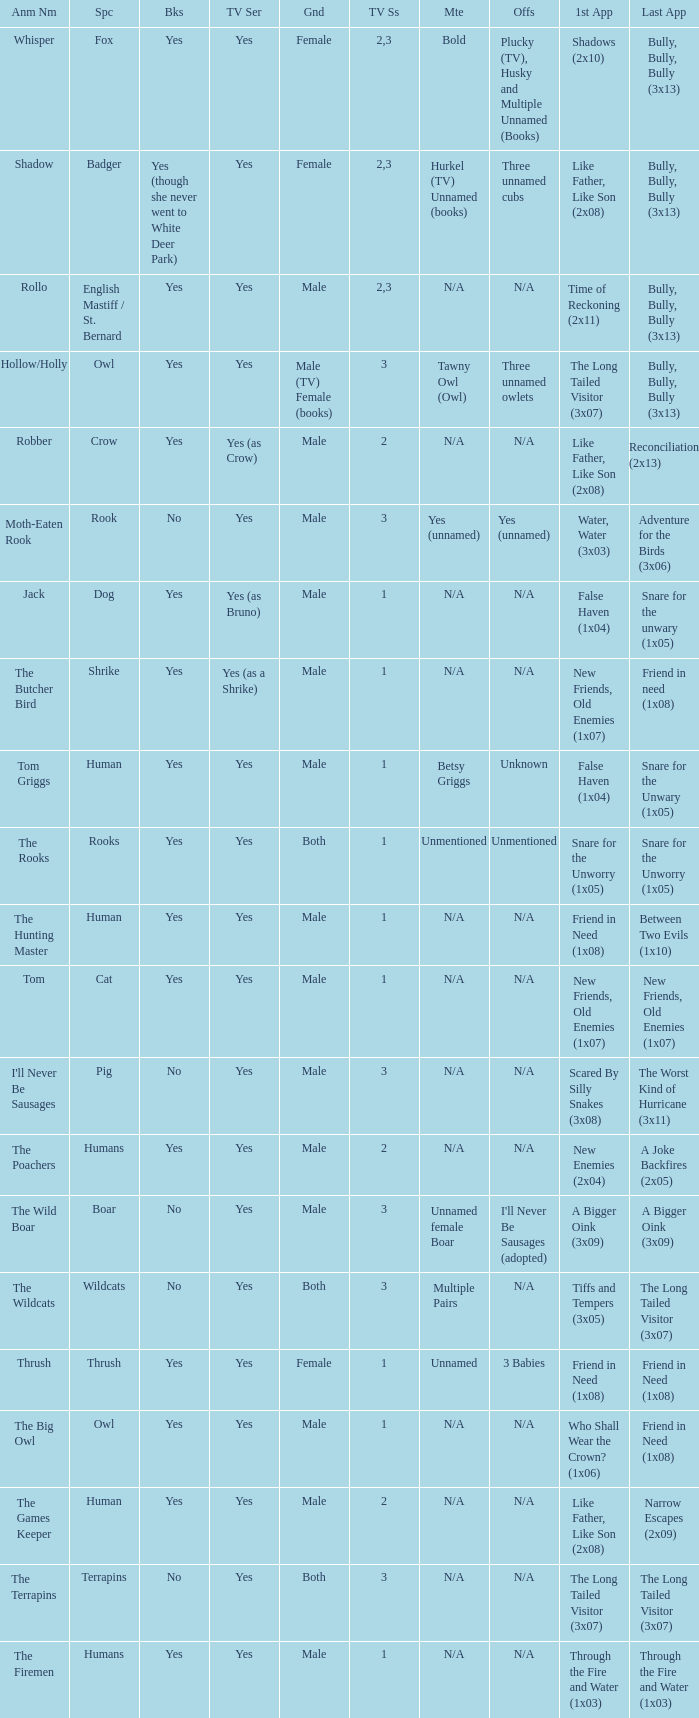Could you parse the entire table as a dict? {'header': ['Anm Nm', 'Spc', 'Bks', 'TV Ser', 'Gnd', 'TV Ss', 'Mte', 'Offs', '1st App', 'Last App'], 'rows': [['Whisper', 'Fox', 'Yes', 'Yes', 'Female', '2,3', 'Bold', 'Plucky (TV), Husky and Multiple Unnamed (Books)', 'Shadows (2x10)', 'Bully, Bully, Bully (3x13)'], ['Shadow', 'Badger', 'Yes (though she never went to White Deer Park)', 'Yes', 'Female', '2,3', 'Hurkel (TV) Unnamed (books)', 'Three unnamed cubs', 'Like Father, Like Son (2x08)', 'Bully, Bully, Bully (3x13)'], ['Rollo', 'English Mastiff / St. Bernard', 'Yes', 'Yes', 'Male', '2,3', 'N/A', 'N/A', 'Time of Reckoning (2x11)', 'Bully, Bully, Bully (3x13)'], ['Hollow/Holly', 'Owl', 'Yes', 'Yes', 'Male (TV) Female (books)', '3', 'Tawny Owl (Owl)', 'Three unnamed owlets', 'The Long Tailed Visitor (3x07)', 'Bully, Bully, Bully (3x13)'], ['Robber', 'Crow', 'Yes', 'Yes (as Crow)', 'Male', '2', 'N/A', 'N/A', 'Like Father, Like Son (2x08)', 'Reconciliation (2x13)'], ['Moth-Eaten Rook', 'Rook', 'No', 'Yes', 'Male', '3', 'Yes (unnamed)', 'Yes (unnamed)', 'Water, Water (3x03)', 'Adventure for the Birds (3x06)'], ['Jack', 'Dog', 'Yes', 'Yes (as Bruno)', 'Male', '1', 'N/A', 'N/A', 'False Haven (1x04)', 'Snare for the unwary (1x05)'], ['The Butcher Bird', 'Shrike', 'Yes', 'Yes (as a Shrike)', 'Male', '1', 'N/A', 'N/A', 'New Friends, Old Enemies (1x07)', 'Friend in need (1x08)'], ['Tom Griggs', 'Human', 'Yes', 'Yes', 'Male', '1', 'Betsy Griggs', 'Unknown', 'False Haven (1x04)', 'Snare for the Unwary (1x05)'], ['The Rooks', 'Rooks', 'Yes', 'Yes', 'Both', '1', 'Unmentioned', 'Unmentioned', 'Snare for the Unworry (1x05)', 'Snare for the Unworry (1x05)'], ['The Hunting Master', 'Human', 'Yes', 'Yes', 'Male', '1', 'N/A', 'N/A', 'Friend in Need (1x08)', 'Between Two Evils (1x10)'], ['Tom', 'Cat', 'Yes', 'Yes', 'Male', '1', 'N/A', 'N/A', 'New Friends, Old Enemies (1x07)', 'New Friends, Old Enemies (1x07)'], ["I'll Never Be Sausages", 'Pig', 'No', 'Yes', 'Male', '3', 'N/A', 'N/A', 'Scared By Silly Snakes (3x08)', 'The Worst Kind of Hurricane (3x11)'], ['The Poachers', 'Humans', 'Yes', 'Yes', 'Male', '2', 'N/A', 'N/A', 'New Enemies (2x04)', 'A Joke Backfires (2x05)'], ['The Wild Boar', 'Boar', 'No', 'Yes', 'Male', '3', 'Unnamed female Boar', "I'll Never Be Sausages (adopted)", 'A Bigger Oink (3x09)', 'A Bigger Oink (3x09)'], ['The Wildcats', 'Wildcats', 'No', 'Yes', 'Both', '3', 'Multiple Pairs', 'N/A', 'Tiffs and Tempers (3x05)', 'The Long Tailed Visitor (3x07)'], ['Thrush', 'Thrush', 'Yes', 'Yes', 'Female', '1', 'Unnamed', '3 Babies', 'Friend in Need (1x08)', 'Friend in Need (1x08)'], ['The Big Owl', 'Owl', 'Yes', 'Yes', 'Male', '1', 'N/A', 'N/A', 'Who Shall Wear the Crown? (1x06)', 'Friend in Need (1x08)'], ['The Games Keeper', 'Human', 'Yes', 'Yes', 'Male', '2', 'N/A', 'N/A', 'Like Father, Like Son (2x08)', 'Narrow Escapes (2x09)'], ['The Terrapins', 'Terrapins', 'No', 'Yes', 'Both', '3', 'N/A', 'N/A', 'The Long Tailed Visitor (3x07)', 'The Long Tailed Visitor (3x07)'], ['The Firemen', 'Humans', 'Yes', 'Yes', 'Male', '1', 'N/A', 'N/A', 'Through the Fire and Water (1x03)', 'Through the Fire and Water (1x03)']]} What is the mate for Last Appearance of bully, bully, bully (3x13) for the animal named hollow/holly later than season 1? Tawny Owl (Owl). 